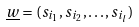<formula> <loc_0><loc_0><loc_500><loc_500>\underline { w } = ( s _ { i _ { 1 } } , s _ { i _ { 2 } } , \dots , s _ { i _ { l } } )</formula> 